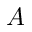<formula> <loc_0><loc_0><loc_500><loc_500>A</formula> 